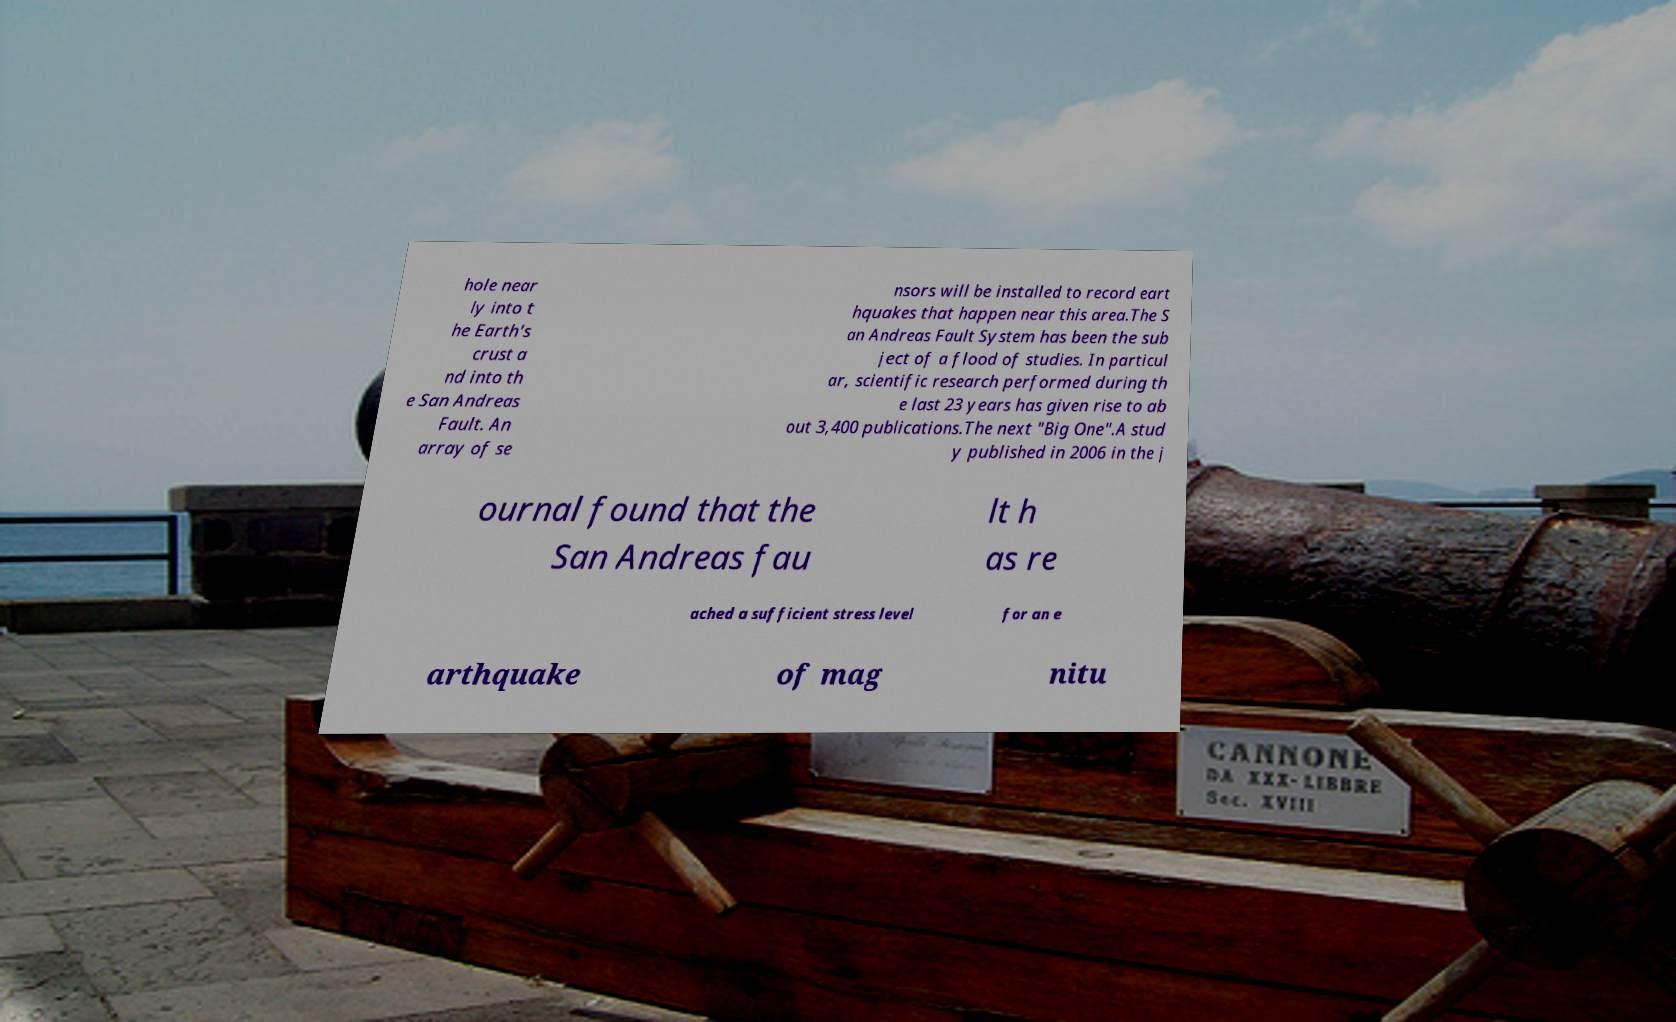Could you assist in decoding the text presented in this image and type it out clearly? hole near ly into t he Earth's crust a nd into th e San Andreas Fault. An array of se nsors will be installed to record eart hquakes that happen near this area.The S an Andreas Fault System has been the sub ject of a flood of studies. In particul ar, scientific research performed during th e last 23 years has given rise to ab out 3,400 publications.The next "Big One".A stud y published in 2006 in the j ournal found that the San Andreas fau lt h as re ached a sufficient stress level for an e arthquake of mag nitu 